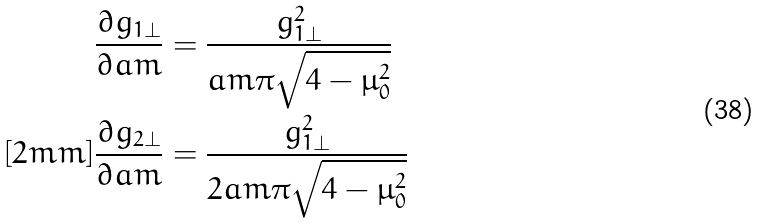Convert formula to latex. <formula><loc_0><loc_0><loc_500><loc_500>\frac { \partial g _ { 1 \perp } } { \partial \L a m } & = \frac { g _ { 1 \perp } ^ { 2 } } { \L a m \pi \sqrt { 4 - \mu _ { 0 } ^ { 2 } } } \\ [ 2 m m ] \frac { \partial g _ { 2 \perp } } { \partial \L a m } & = \frac { g _ { 1 \perp } ^ { 2 } } { 2 \L a m \pi \sqrt { 4 - \mu _ { 0 } ^ { 2 } } }</formula> 